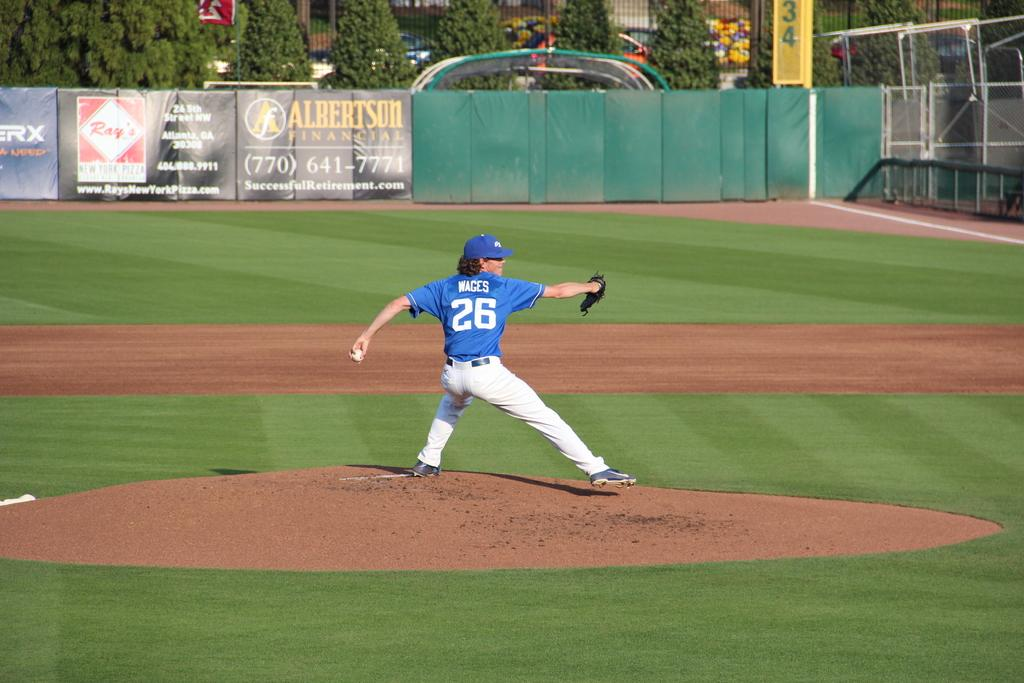<image>
Render a clear and concise summary of the photo. A baseball pitcher named Wages wearing number 26 begins to throw a pitch. 